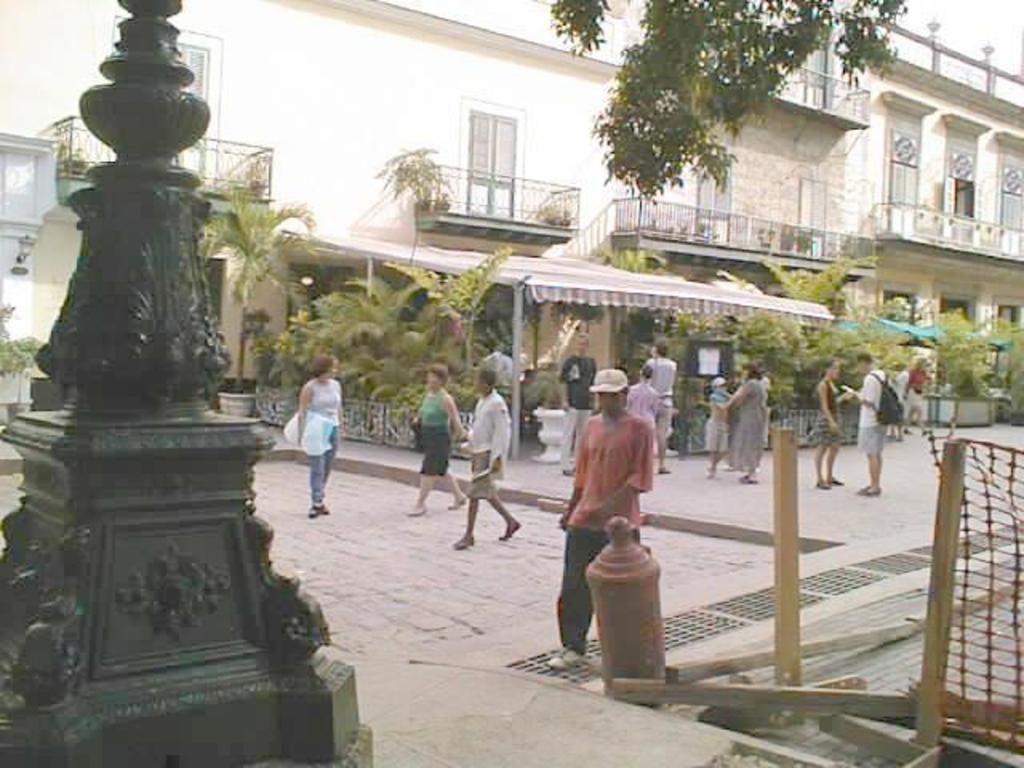Describe this image in one or two sentences. On the left side there is a pole on a platform. In the background there are few persons standing and walking on the road,poles,trees,buildings,windows,plants and doors and on the right side there is a fence and wooden poles. 